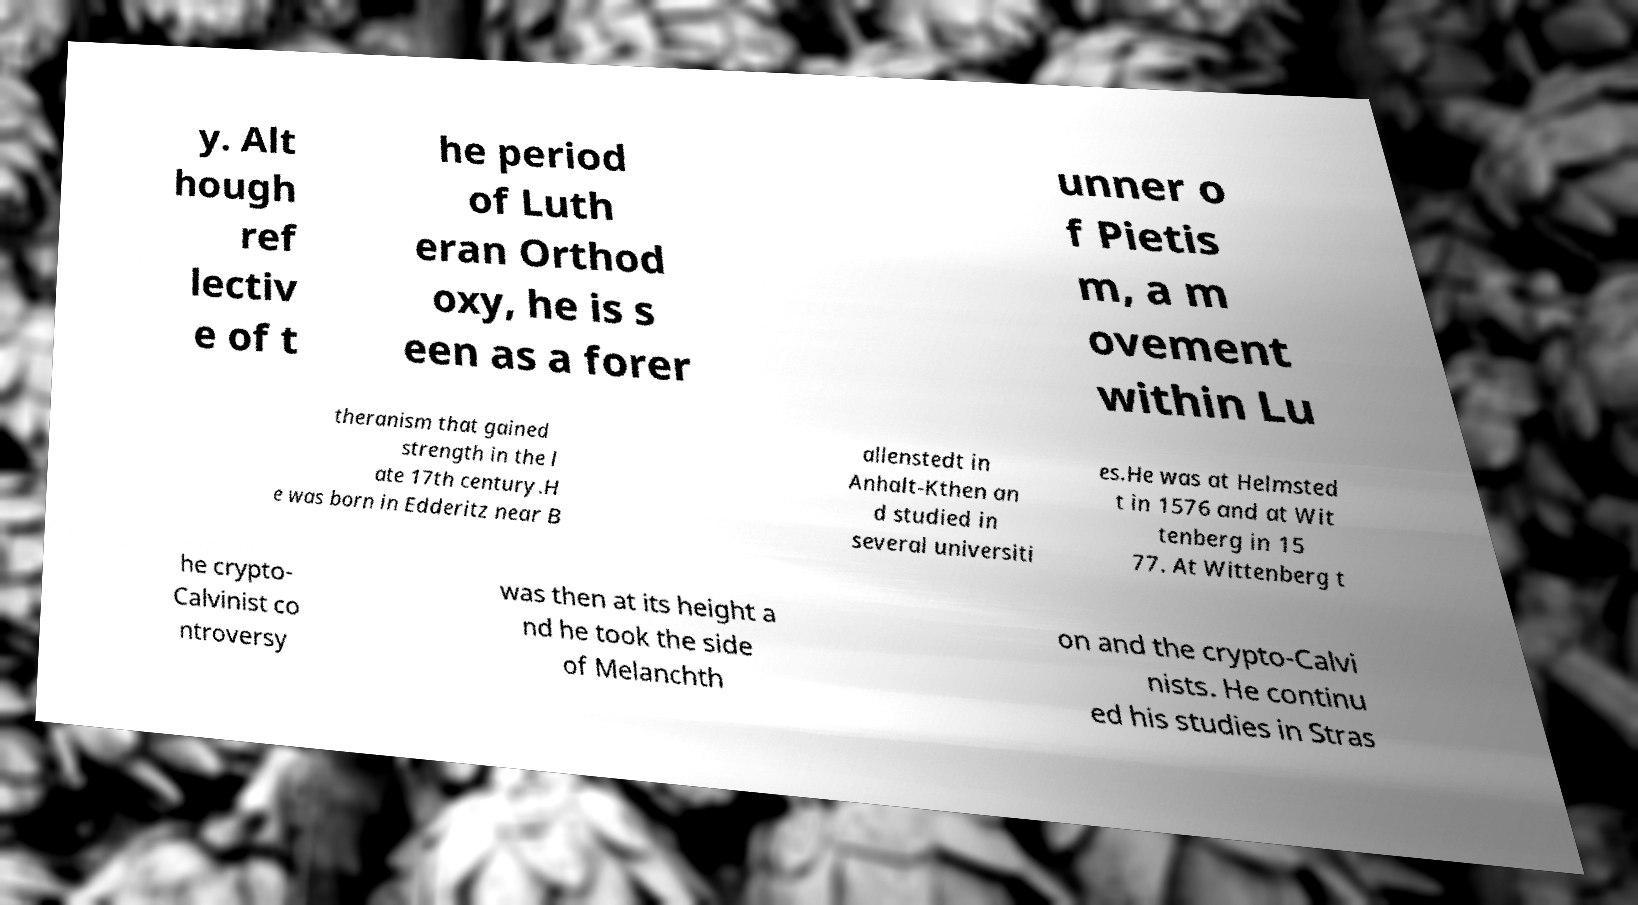Can you accurately transcribe the text from the provided image for me? y. Alt hough ref lectiv e of t he period of Luth eran Orthod oxy, he is s een as a forer unner o f Pietis m, a m ovement within Lu theranism that gained strength in the l ate 17th century.H e was born in Edderitz near B allenstedt in Anhalt-Kthen an d studied in several universiti es.He was at Helmsted t in 1576 and at Wit tenberg in 15 77. At Wittenberg t he crypto- Calvinist co ntroversy was then at its height a nd he took the side of Melanchth on and the crypto-Calvi nists. He continu ed his studies in Stras 